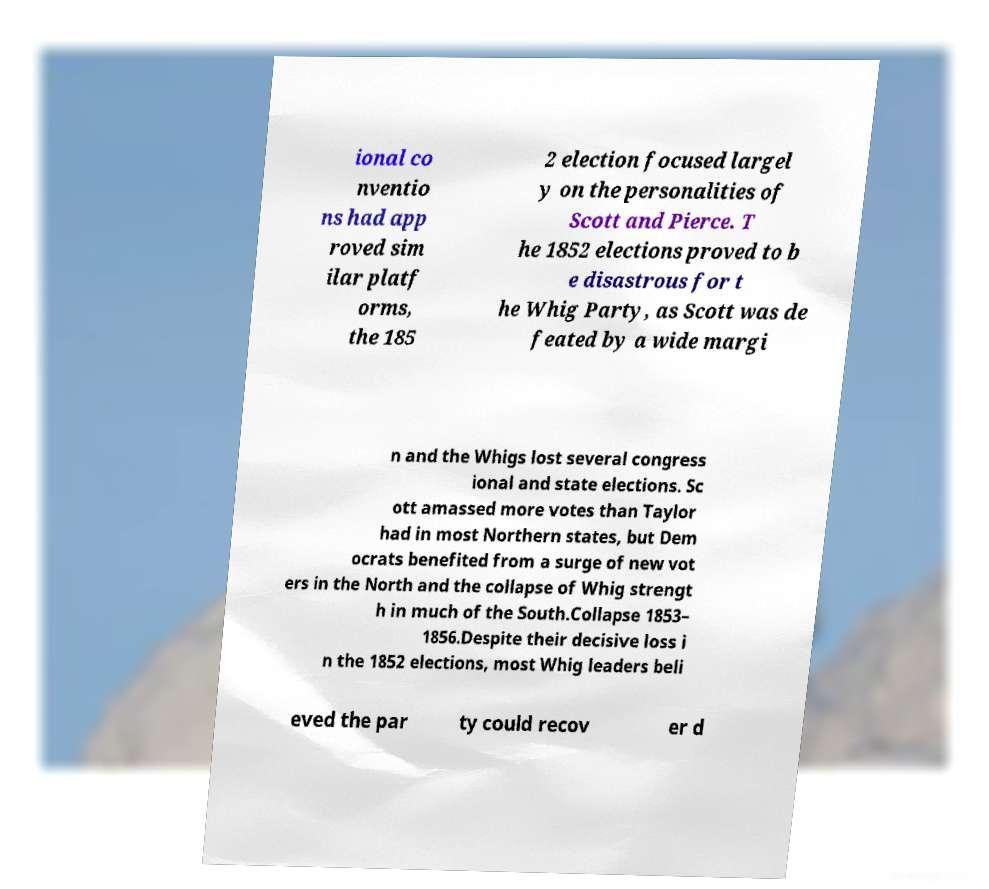Can you read and provide the text displayed in the image?This photo seems to have some interesting text. Can you extract and type it out for me? ional co nventio ns had app roved sim ilar platf orms, the 185 2 election focused largel y on the personalities of Scott and Pierce. T he 1852 elections proved to b e disastrous for t he Whig Party, as Scott was de feated by a wide margi n and the Whigs lost several congress ional and state elections. Sc ott amassed more votes than Taylor had in most Northern states, but Dem ocrats benefited from a surge of new vot ers in the North and the collapse of Whig strengt h in much of the South.Collapse 1853– 1856.Despite their decisive loss i n the 1852 elections, most Whig leaders beli eved the par ty could recov er d 